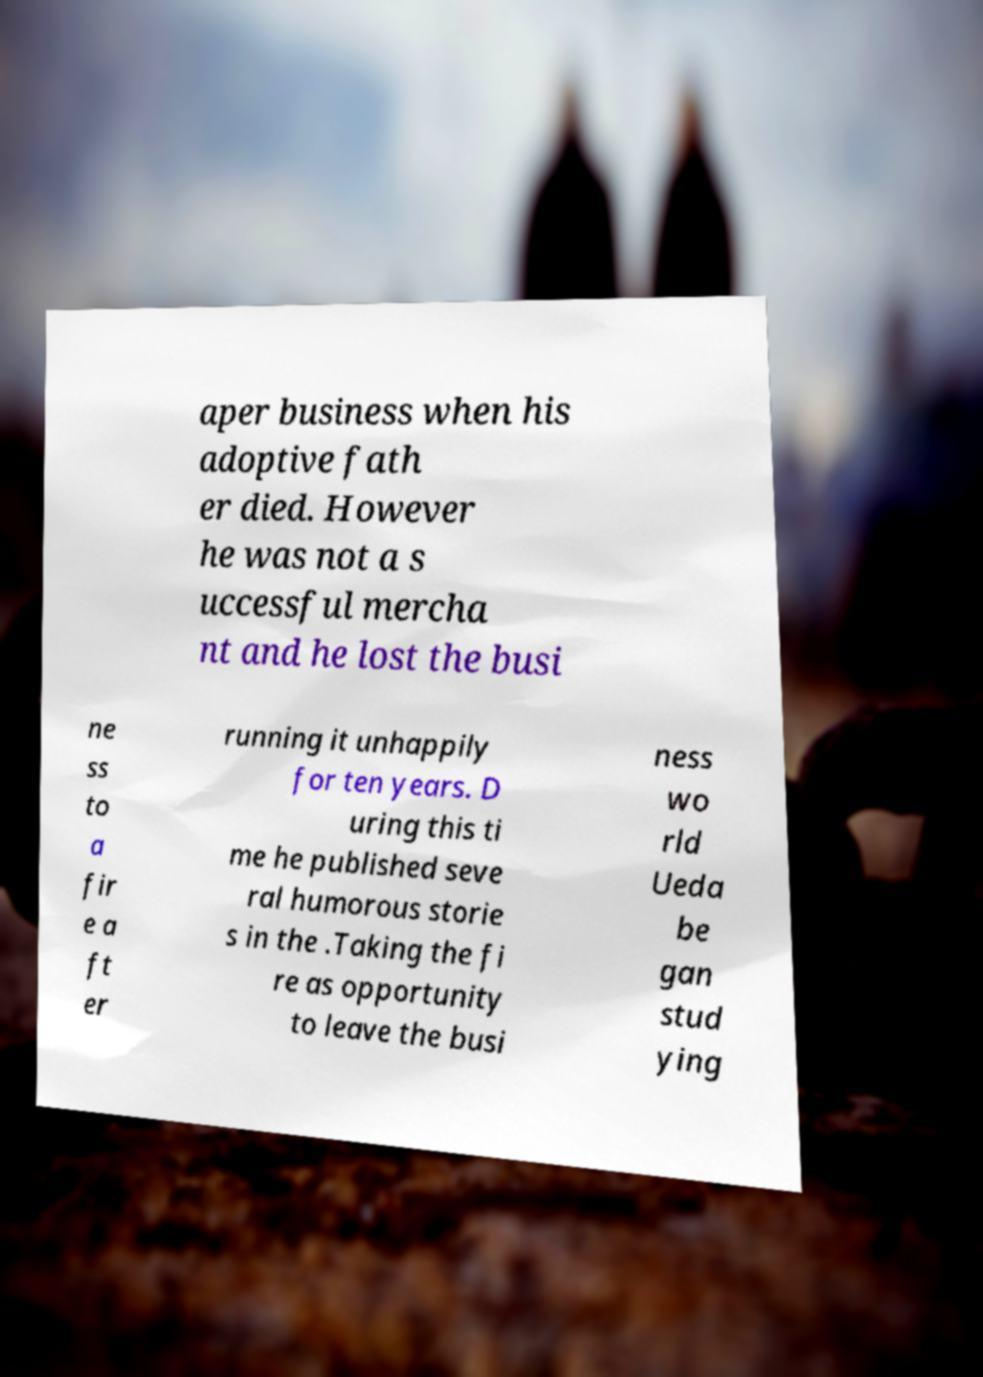Could you assist in decoding the text presented in this image and type it out clearly? aper business when his adoptive fath er died. However he was not a s uccessful mercha nt and he lost the busi ne ss to a fir e a ft er running it unhappily for ten years. D uring this ti me he published seve ral humorous storie s in the .Taking the fi re as opportunity to leave the busi ness wo rld Ueda be gan stud ying 